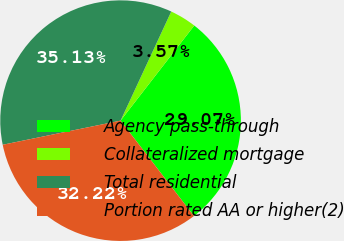Convert chart. <chart><loc_0><loc_0><loc_500><loc_500><pie_chart><fcel>Agency pass-through<fcel>Collateralized mortgage<fcel>Total residential<fcel>Portion rated AA or higher(2)<nl><fcel>29.07%<fcel>3.57%<fcel>35.13%<fcel>32.22%<nl></chart> 